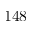Convert formula to latex. <formula><loc_0><loc_0><loc_500><loc_500>1 4 8</formula> 